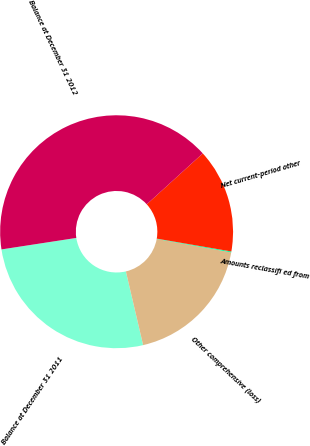<chart> <loc_0><loc_0><loc_500><loc_500><pie_chart><fcel>Balance at December 31 2011<fcel>Other comprehensive (loss)<fcel>Amounts reclassifi ed from<fcel>Net current-period other<fcel>Balance at December 31 2012<nl><fcel>26.23%<fcel>18.5%<fcel>0.13%<fcel>14.45%<fcel>40.68%<nl></chart> 